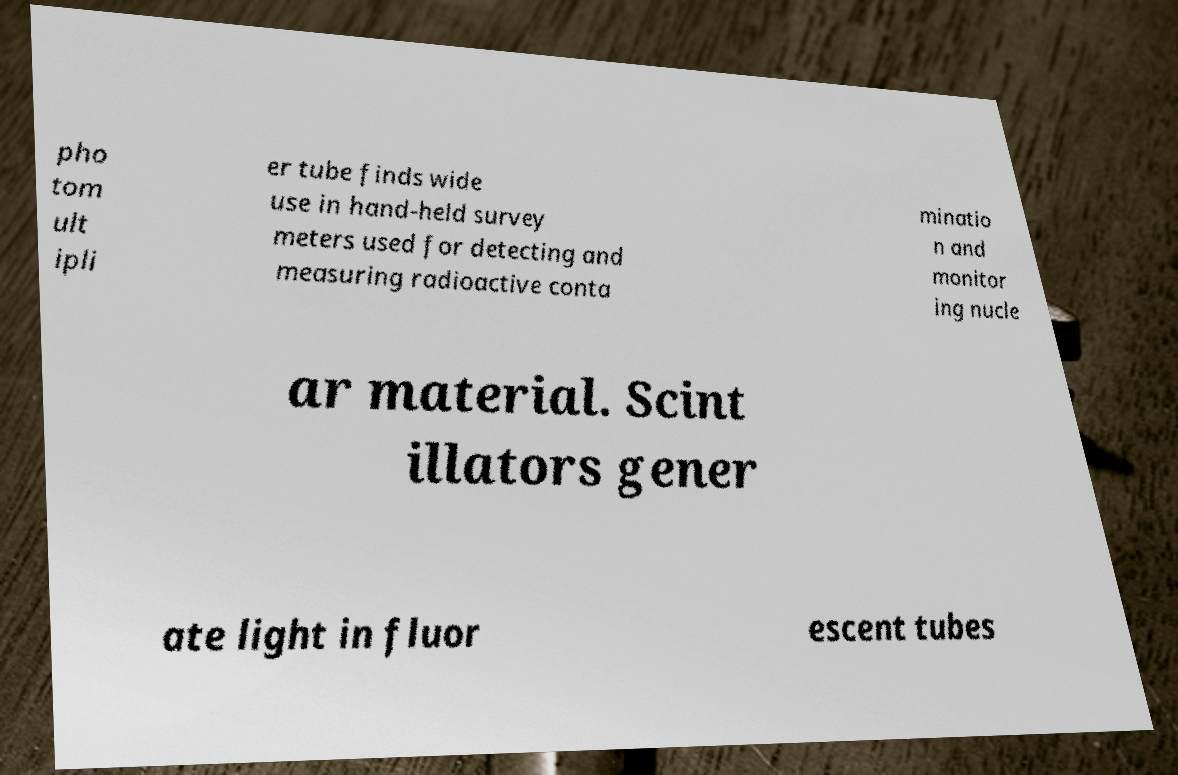For documentation purposes, I need the text within this image transcribed. Could you provide that? pho tom ult ipli er tube finds wide use in hand-held survey meters used for detecting and measuring radioactive conta minatio n and monitor ing nucle ar material. Scint illators gener ate light in fluor escent tubes 